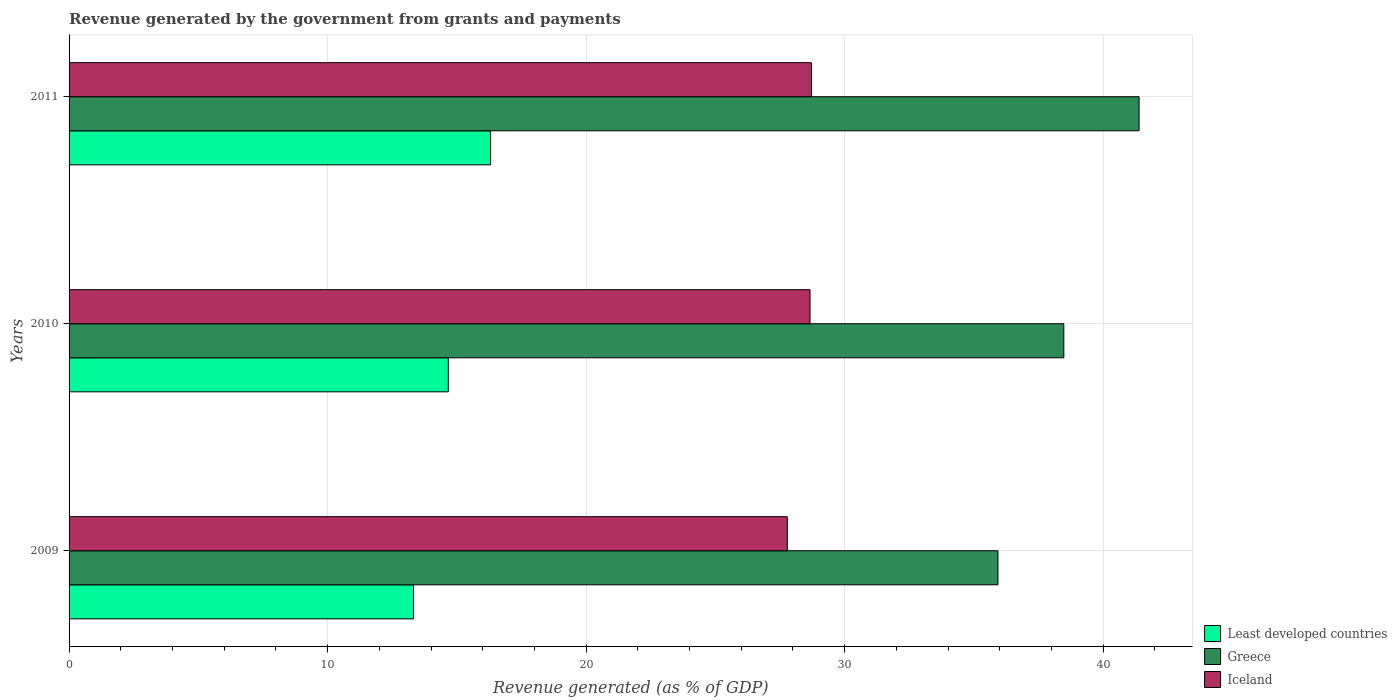How many different coloured bars are there?
Keep it short and to the point. 3. How many groups of bars are there?
Give a very brief answer. 3. Are the number of bars on each tick of the Y-axis equal?
Offer a very short reply. Yes. How many bars are there on the 2nd tick from the bottom?
Offer a terse response. 3. What is the label of the 2nd group of bars from the top?
Keep it short and to the point. 2010. In how many cases, is the number of bars for a given year not equal to the number of legend labels?
Your answer should be very brief. 0. What is the revenue generated by the government in Greece in 2010?
Keep it short and to the point. 38.48. Across all years, what is the maximum revenue generated by the government in Least developed countries?
Offer a terse response. 16.3. Across all years, what is the minimum revenue generated by the government in Least developed countries?
Your answer should be very brief. 13.32. What is the total revenue generated by the government in Greece in the graph?
Keep it short and to the point. 115.79. What is the difference between the revenue generated by the government in Iceland in 2010 and that in 2011?
Your response must be concise. -0.06. What is the difference between the revenue generated by the government in Least developed countries in 2010 and the revenue generated by the government in Greece in 2009?
Offer a very short reply. -21.26. What is the average revenue generated by the government in Least developed countries per year?
Provide a succinct answer. 14.77. In the year 2010, what is the difference between the revenue generated by the government in Iceland and revenue generated by the government in Greece?
Offer a terse response. -9.82. In how many years, is the revenue generated by the government in Least developed countries greater than 8 %?
Provide a short and direct response. 3. What is the ratio of the revenue generated by the government in Least developed countries in 2009 to that in 2011?
Ensure brevity in your answer.  0.82. Is the revenue generated by the government in Greece in 2009 less than that in 2010?
Keep it short and to the point. Yes. What is the difference between the highest and the second highest revenue generated by the government in Least developed countries?
Your response must be concise. 1.64. What is the difference between the highest and the lowest revenue generated by the government in Iceland?
Provide a succinct answer. 0.94. In how many years, is the revenue generated by the government in Greece greater than the average revenue generated by the government in Greece taken over all years?
Ensure brevity in your answer.  1. What does the 2nd bar from the top in 2009 represents?
Keep it short and to the point. Greece. How many bars are there?
Your answer should be compact. 9. How many years are there in the graph?
Ensure brevity in your answer.  3. What is the difference between two consecutive major ticks on the X-axis?
Your answer should be very brief. 10. Are the values on the major ticks of X-axis written in scientific E-notation?
Provide a succinct answer. No. Does the graph contain grids?
Keep it short and to the point. Yes. How many legend labels are there?
Give a very brief answer. 3. What is the title of the graph?
Your answer should be compact. Revenue generated by the government from grants and payments. Does "Netherlands" appear as one of the legend labels in the graph?
Your answer should be very brief. No. What is the label or title of the X-axis?
Keep it short and to the point. Revenue generated (as % of GDP). What is the Revenue generated (as % of GDP) of Least developed countries in 2009?
Offer a terse response. 13.32. What is the Revenue generated (as % of GDP) in Greece in 2009?
Offer a terse response. 35.93. What is the Revenue generated (as % of GDP) in Iceland in 2009?
Offer a very short reply. 27.78. What is the Revenue generated (as % of GDP) in Least developed countries in 2010?
Your response must be concise. 14.67. What is the Revenue generated (as % of GDP) of Greece in 2010?
Offer a terse response. 38.48. What is the Revenue generated (as % of GDP) in Iceland in 2010?
Offer a very short reply. 28.66. What is the Revenue generated (as % of GDP) of Least developed countries in 2011?
Provide a succinct answer. 16.3. What is the Revenue generated (as % of GDP) of Greece in 2011?
Provide a succinct answer. 41.39. What is the Revenue generated (as % of GDP) in Iceland in 2011?
Your response must be concise. 28.72. Across all years, what is the maximum Revenue generated (as % of GDP) in Least developed countries?
Your answer should be compact. 16.3. Across all years, what is the maximum Revenue generated (as % of GDP) of Greece?
Ensure brevity in your answer.  41.39. Across all years, what is the maximum Revenue generated (as % of GDP) in Iceland?
Your answer should be very brief. 28.72. Across all years, what is the minimum Revenue generated (as % of GDP) of Least developed countries?
Give a very brief answer. 13.32. Across all years, what is the minimum Revenue generated (as % of GDP) of Greece?
Keep it short and to the point. 35.93. Across all years, what is the minimum Revenue generated (as % of GDP) of Iceland?
Make the answer very short. 27.78. What is the total Revenue generated (as % of GDP) of Least developed countries in the graph?
Give a very brief answer. 44.3. What is the total Revenue generated (as % of GDP) of Greece in the graph?
Provide a short and direct response. 115.79. What is the total Revenue generated (as % of GDP) in Iceland in the graph?
Offer a terse response. 85.16. What is the difference between the Revenue generated (as % of GDP) of Least developed countries in 2009 and that in 2010?
Your answer should be compact. -1.35. What is the difference between the Revenue generated (as % of GDP) in Greece in 2009 and that in 2010?
Ensure brevity in your answer.  -2.55. What is the difference between the Revenue generated (as % of GDP) of Iceland in 2009 and that in 2010?
Offer a terse response. -0.88. What is the difference between the Revenue generated (as % of GDP) of Least developed countries in 2009 and that in 2011?
Make the answer very short. -2.98. What is the difference between the Revenue generated (as % of GDP) of Greece in 2009 and that in 2011?
Offer a terse response. -5.46. What is the difference between the Revenue generated (as % of GDP) of Iceland in 2009 and that in 2011?
Make the answer very short. -0.94. What is the difference between the Revenue generated (as % of GDP) of Least developed countries in 2010 and that in 2011?
Offer a terse response. -1.64. What is the difference between the Revenue generated (as % of GDP) in Greece in 2010 and that in 2011?
Give a very brief answer. -2.91. What is the difference between the Revenue generated (as % of GDP) in Iceland in 2010 and that in 2011?
Make the answer very short. -0.06. What is the difference between the Revenue generated (as % of GDP) in Least developed countries in 2009 and the Revenue generated (as % of GDP) in Greece in 2010?
Offer a very short reply. -25.15. What is the difference between the Revenue generated (as % of GDP) in Least developed countries in 2009 and the Revenue generated (as % of GDP) in Iceland in 2010?
Your answer should be compact. -15.34. What is the difference between the Revenue generated (as % of GDP) in Greece in 2009 and the Revenue generated (as % of GDP) in Iceland in 2010?
Your response must be concise. 7.27. What is the difference between the Revenue generated (as % of GDP) in Least developed countries in 2009 and the Revenue generated (as % of GDP) in Greece in 2011?
Offer a terse response. -28.07. What is the difference between the Revenue generated (as % of GDP) of Least developed countries in 2009 and the Revenue generated (as % of GDP) of Iceland in 2011?
Offer a terse response. -15.39. What is the difference between the Revenue generated (as % of GDP) in Greece in 2009 and the Revenue generated (as % of GDP) in Iceland in 2011?
Provide a short and direct response. 7.21. What is the difference between the Revenue generated (as % of GDP) in Least developed countries in 2010 and the Revenue generated (as % of GDP) in Greece in 2011?
Provide a succinct answer. -26.72. What is the difference between the Revenue generated (as % of GDP) in Least developed countries in 2010 and the Revenue generated (as % of GDP) in Iceland in 2011?
Keep it short and to the point. -14.05. What is the difference between the Revenue generated (as % of GDP) of Greece in 2010 and the Revenue generated (as % of GDP) of Iceland in 2011?
Your answer should be compact. 9.76. What is the average Revenue generated (as % of GDP) of Least developed countries per year?
Provide a short and direct response. 14.77. What is the average Revenue generated (as % of GDP) of Greece per year?
Offer a terse response. 38.6. What is the average Revenue generated (as % of GDP) of Iceland per year?
Offer a terse response. 28.39. In the year 2009, what is the difference between the Revenue generated (as % of GDP) in Least developed countries and Revenue generated (as % of GDP) in Greece?
Keep it short and to the point. -22.61. In the year 2009, what is the difference between the Revenue generated (as % of GDP) in Least developed countries and Revenue generated (as % of GDP) in Iceland?
Give a very brief answer. -14.46. In the year 2009, what is the difference between the Revenue generated (as % of GDP) of Greece and Revenue generated (as % of GDP) of Iceland?
Make the answer very short. 8.15. In the year 2010, what is the difference between the Revenue generated (as % of GDP) of Least developed countries and Revenue generated (as % of GDP) of Greece?
Provide a succinct answer. -23.81. In the year 2010, what is the difference between the Revenue generated (as % of GDP) in Least developed countries and Revenue generated (as % of GDP) in Iceland?
Your answer should be very brief. -13.99. In the year 2010, what is the difference between the Revenue generated (as % of GDP) in Greece and Revenue generated (as % of GDP) in Iceland?
Give a very brief answer. 9.82. In the year 2011, what is the difference between the Revenue generated (as % of GDP) in Least developed countries and Revenue generated (as % of GDP) in Greece?
Your response must be concise. -25.08. In the year 2011, what is the difference between the Revenue generated (as % of GDP) in Least developed countries and Revenue generated (as % of GDP) in Iceland?
Offer a terse response. -12.41. In the year 2011, what is the difference between the Revenue generated (as % of GDP) of Greece and Revenue generated (as % of GDP) of Iceland?
Ensure brevity in your answer.  12.67. What is the ratio of the Revenue generated (as % of GDP) in Least developed countries in 2009 to that in 2010?
Provide a short and direct response. 0.91. What is the ratio of the Revenue generated (as % of GDP) in Greece in 2009 to that in 2010?
Provide a succinct answer. 0.93. What is the ratio of the Revenue generated (as % of GDP) in Iceland in 2009 to that in 2010?
Your response must be concise. 0.97. What is the ratio of the Revenue generated (as % of GDP) in Least developed countries in 2009 to that in 2011?
Give a very brief answer. 0.82. What is the ratio of the Revenue generated (as % of GDP) in Greece in 2009 to that in 2011?
Your answer should be very brief. 0.87. What is the ratio of the Revenue generated (as % of GDP) of Iceland in 2009 to that in 2011?
Your response must be concise. 0.97. What is the ratio of the Revenue generated (as % of GDP) in Least developed countries in 2010 to that in 2011?
Keep it short and to the point. 0.9. What is the ratio of the Revenue generated (as % of GDP) of Greece in 2010 to that in 2011?
Make the answer very short. 0.93. What is the difference between the highest and the second highest Revenue generated (as % of GDP) of Least developed countries?
Give a very brief answer. 1.64. What is the difference between the highest and the second highest Revenue generated (as % of GDP) in Greece?
Ensure brevity in your answer.  2.91. What is the difference between the highest and the second highest Revenue generated (as % of GDP) in Iceland?
Give a very brief answer. 0.06. What is the difference between the highest and the lowest Revenue generated (as % of GDP) in Least developed countries?
Provide a short and direct response. 2.98. What is the difference between the highest and the lowest Revenue generated (as % of GDP) of Greece?
Provide a succinct answer. 5.46. What is the difference between the highest and the lowest Revenue generated (as % of GDP) of Iceland?
Offer a very short reply. 0.94. 